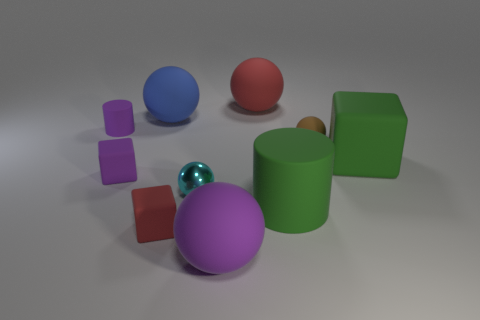Subtract all purple matte cubes. How many cubes are left? 2 Subtract all brown balls. How many balls are left? 4 Subtract all brown spheres. Subtract all yellow blocks. How many spheres are left? 4 Subtract all red spheres. How many purple cylinders are left? 1 Subtract all tiny gray shiny blocks. Subtract all cyan metal things. How many objects are left? 9 Add 1 red rubber spheres. How many red rubber spheres are left? 2 Add 4 tiny shiny things. How many tiny shiny things exist? 5 Subtract 0 blue blocks. How many objects are left? 10 Subtract all cubes. How many objects are left? 7 